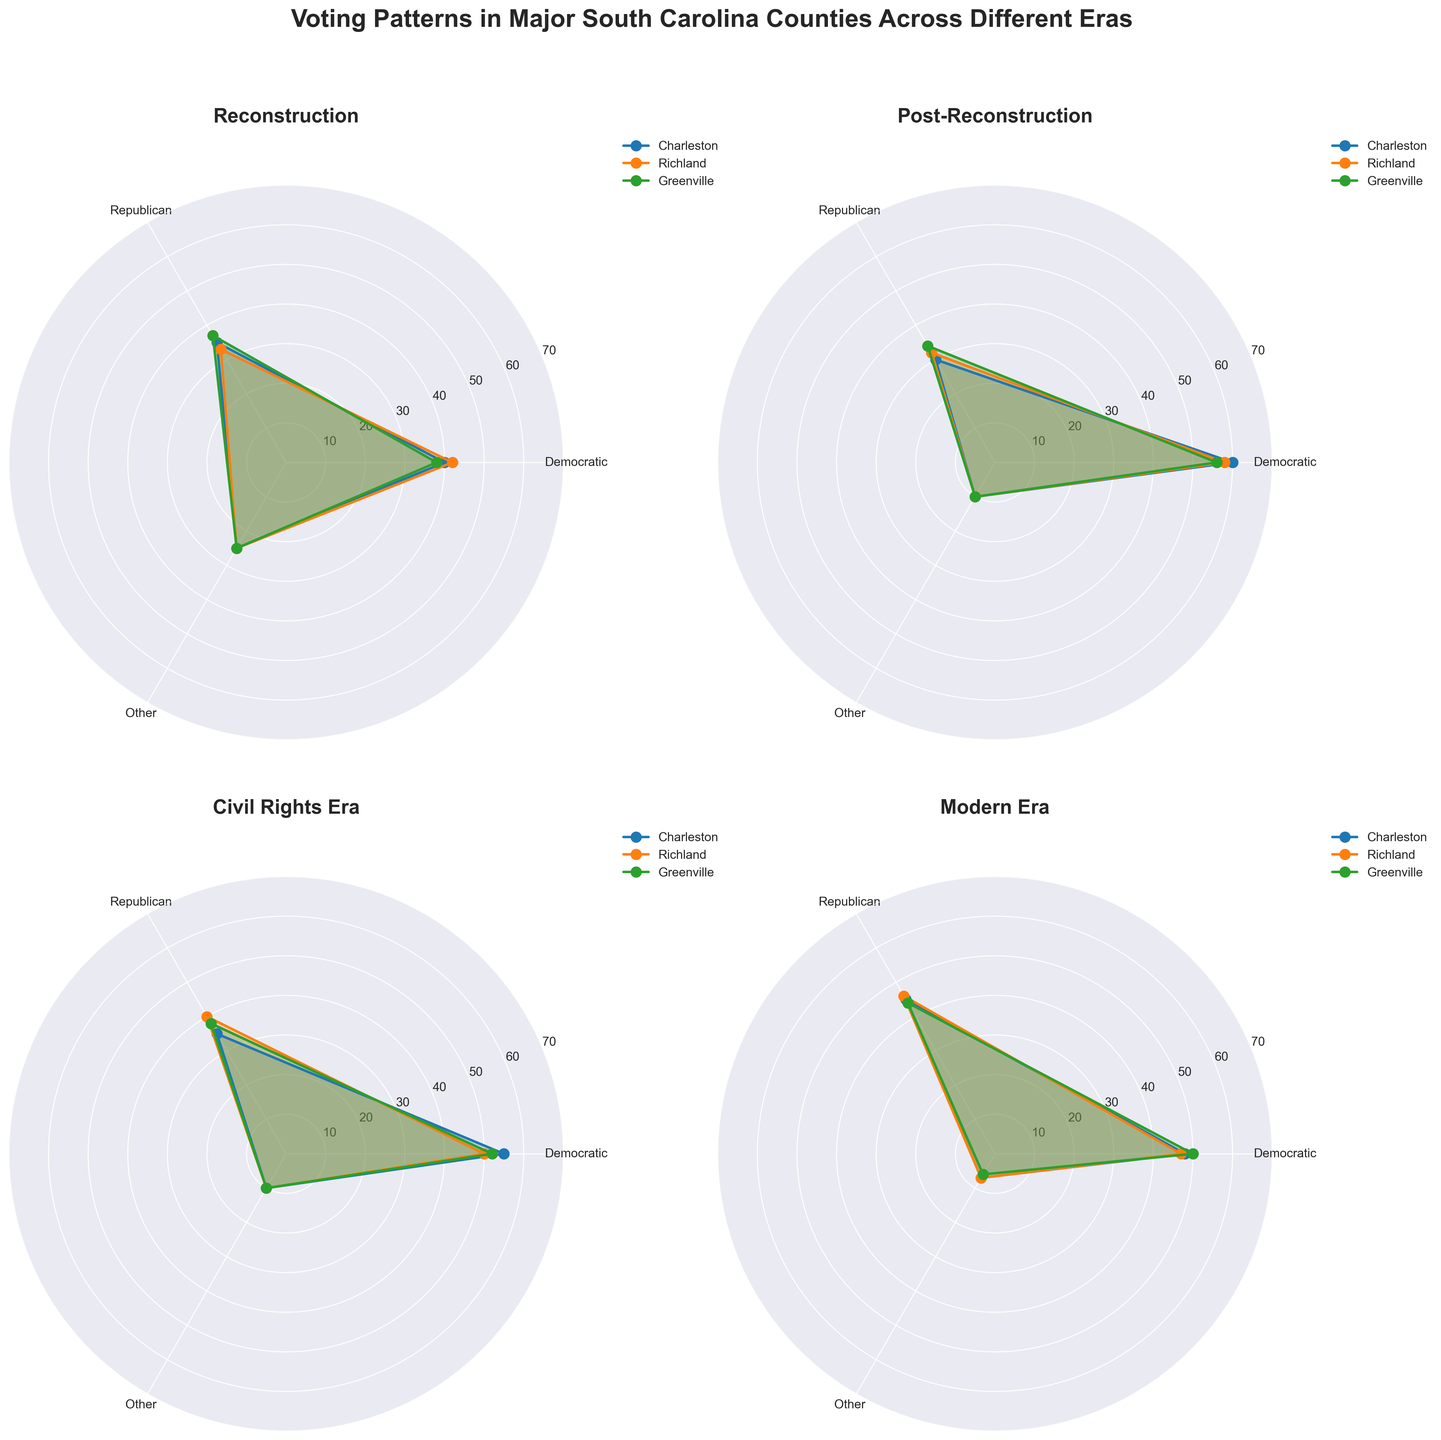What's the title of the figure? The title of the figure is "Voting Patterns in Major South Carolina Counties Across Different Eras," as shown at the top of the plot.
Answer: Voting Patterns in Major South Carolina Counties Across Different Eras Which era shows the highest Democratic vote percentage for Charleston? In the figure, look at the top value of the Democratic vote for Charleston across the subplots. The highest value is in the Post-Reconstruction subplot, with 60%.
Answer: Post-Reconstruction How do the Democratic and Republican vote percentages for Richland in the Civil Rights Era compare? For the Civil Rights Era subplot, examine the lines for Democratic and Republican percentages for Richland. The Democratic percentage is 50%, and the Republican percentage is 40%, showing a 10% higher Democratic vote.
Answer: Democratic: 50%, Republican: 40% What is the average percentage of "Other" votes in the Modern Era across all counties? In the Modern Era subplot, locate the "Other" votes for Charleston (7%), Richland (7%), and Greenville (6%). The average is calculated as (7 + 7 + 6) / 3 = 6.67%.
Answer: 6.67% Which era shows the smallest gap between Democratic and Republican votes in Greenville? Compare the differences between Democratic and Republican vote percentages for Greenville across all eras. The smallest gap is in the Reconstruction subplot, where the difference is 1% (38% Democratic and 37% Republican).
Answer: Reconstruction What is the trend in "Other" votes from Post-Reconstruction to the Modern Era in Charleston? Examine the "Other" votes in Charleston from Post-Reconstruction (10%), Civil Rights Era (10%), and Modern Era (7%). The trend shows a decrease over time.
Answer: Decreasing In which era did Charleston have a higher Republican vote percentage than Richland? Compare the Republican vote percentages for Charleston and Richland across all eras. In the Reconstruction era, Charleston has 35% while Richland has 33%, indicating a higher vote percentage for Charleston.
Answer: Reconstruction What's the sum of Democratic votes in all counties during the Civil Rights Era? Add the Democratic vote percentages for Charleston (55%), Richland (50%), and Greenville (52%) during the Civil Rights Era: 55 + 50 + 52 = 157%.
Answer: 157% 